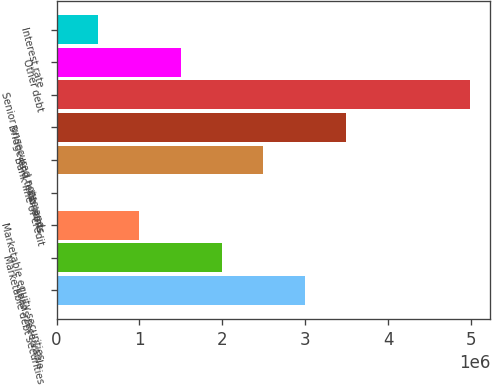<chart> <loc_0><loc_0><loc_500><loc_500><bar_chart><fcel>Loans receivable<fcel>Marketable debt securities<fcel>Marketable equity securities<fcel>Warrants<fcel>Bank line of credit<fcel>Bridge and term loans<fcel>Senior unsecured notes and<fcel>Other debt<fcel>Interest rate<nl><fcel>2.99048e+06<fcel>1.9945e+06<fcel>998532<fcel>2560<fcel>2.49249e+06<fcel>3.48846e+06<fcel>4.98242e+06<fcel>1.49652e+06<fcel>500546<nl></chart> 